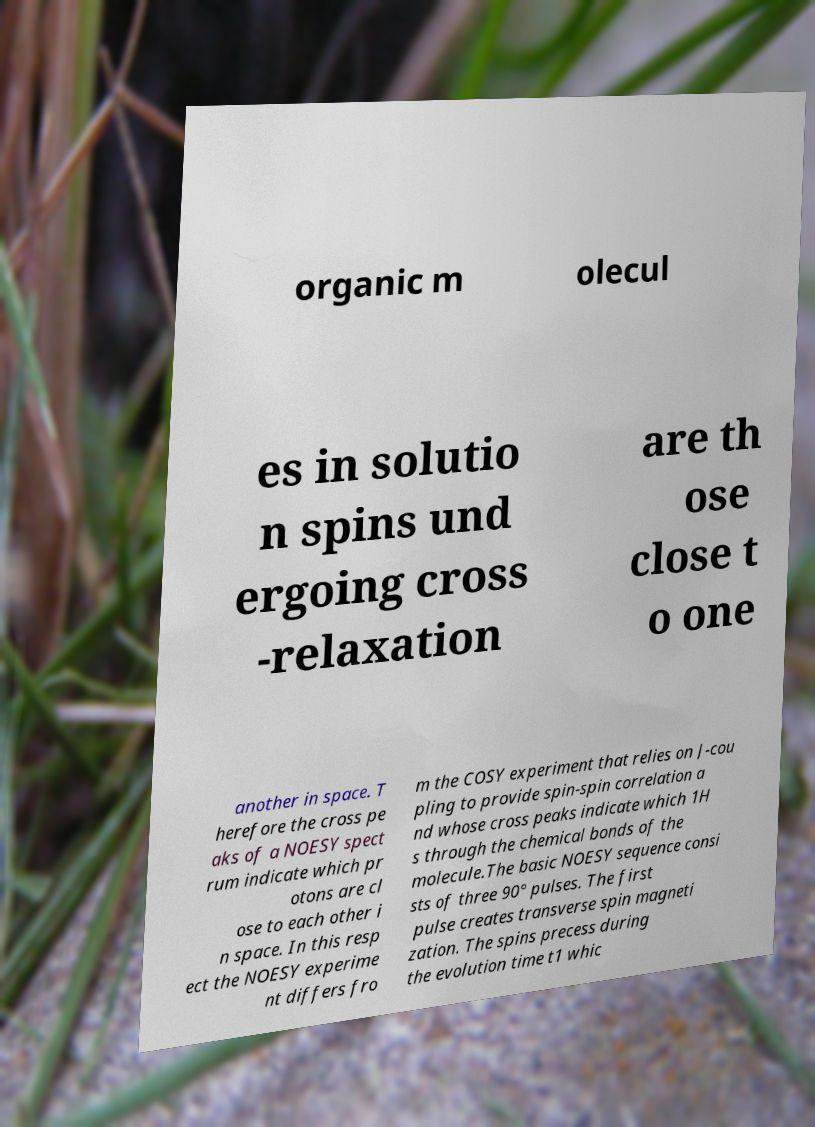Please identify and transcribe the text found in this image. organic m olecul es in solutio n spins und ergoing cross -relaxation are th ose close t o one another in space. T herefore the cross pe aks of a NOESY spect rum indicate which pr otons are cl ose to each other i n space. In this resp ect the NOESY experime nt differs fro m the COSY experiment that relies on J-cou pling to provide spin-spin correlation a nd whose cross peaks indicate which 1H s through the chemical bonds of the molecule.The basic NOESY sequence consi sts of three 90° pulses. The first pulse creates transverse spin magneti zation. The spins precess during the evolution time t1 whic 